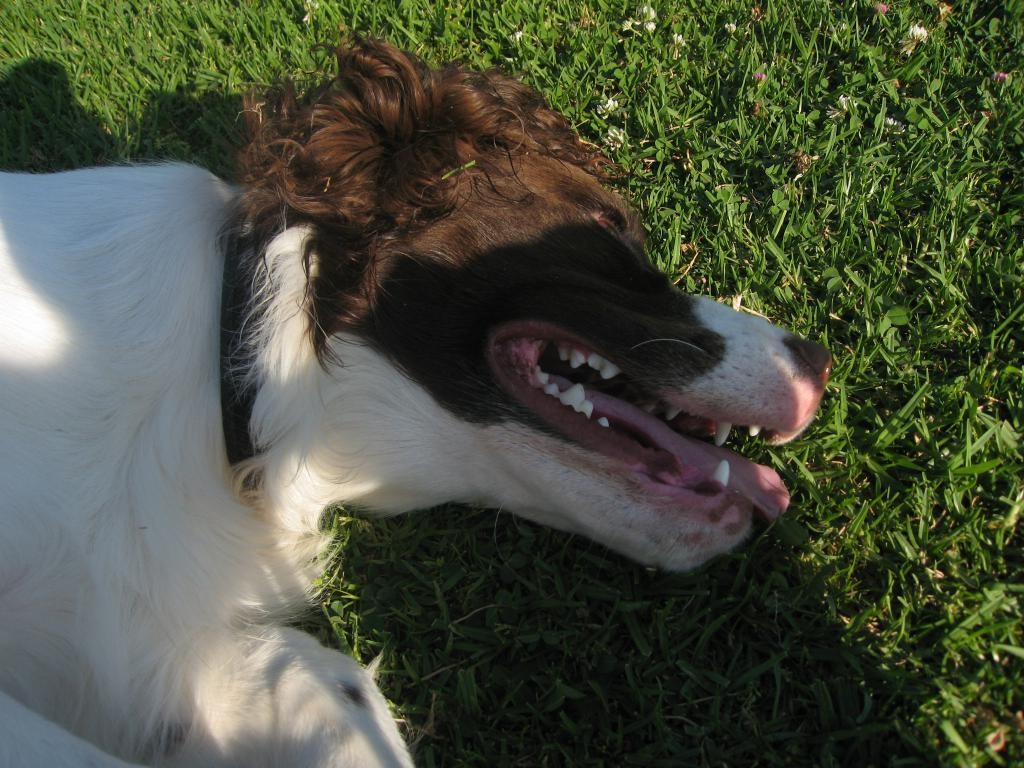What type of animal is in the image? There is a dog in the image. Where is the dog located in the image? The dog is on the left side of the image. What type of terrain is the dog on? The dog is on grassland. What type of action is the zipper performing in the image? There is no zipper present in the image, so it cannot perform any action. 